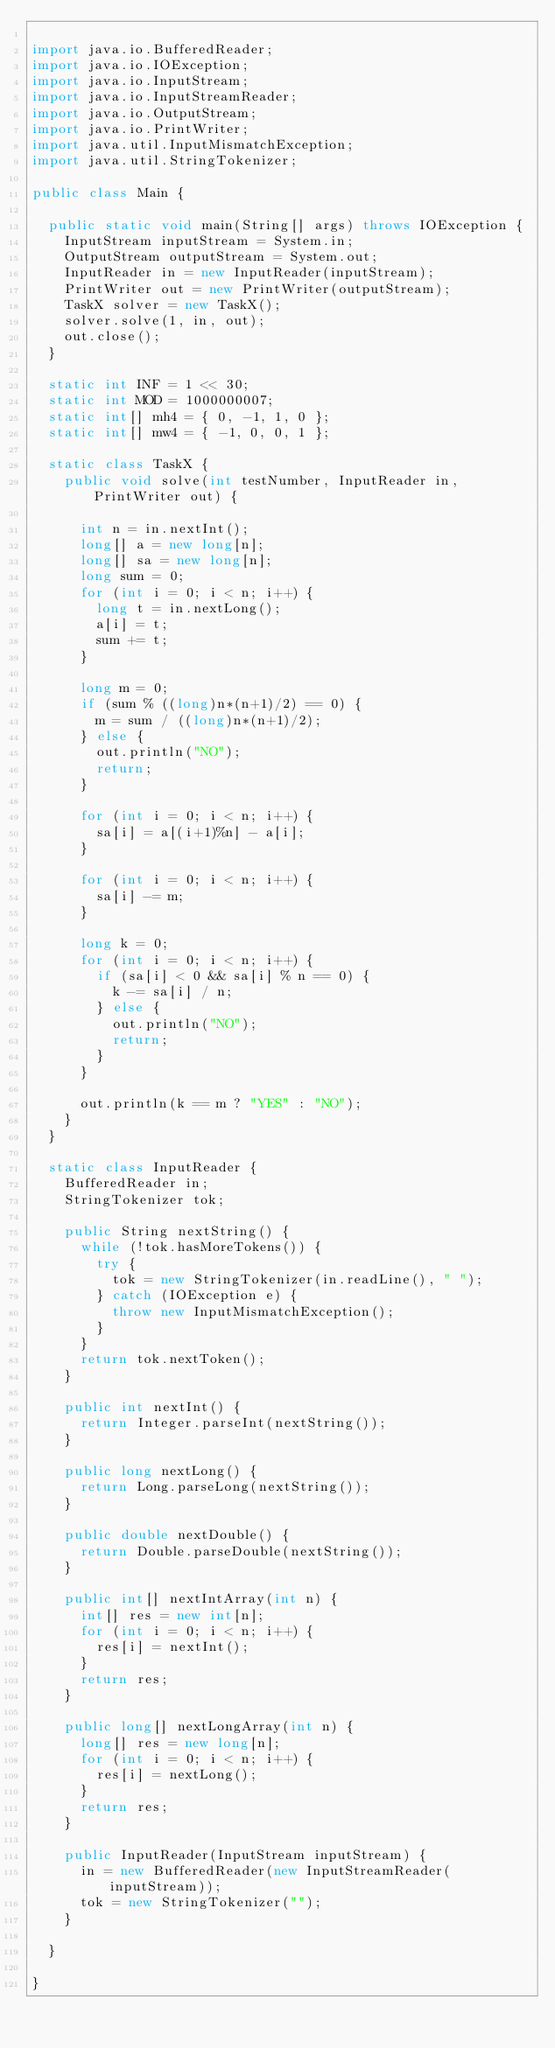Convert code to text. <code><loc_0><loc_0><loc_500><loc_500><_Java_>
import java.io.BufferedReader;
import java.io.IOException;
import java.io.InputStream;
import java.io.InputStreamReader;
import java.io.OutputStream;
import java.io.PrintWriter;
import java.util.InputMismatchException;
import java.util.StringTokenizer;

public class Main {

	public static void main(String[] args) throws IOException {
		InputStream inputStream = System.in;
		OutputStream outputStream = System.out;
		InputReader in = new InputReader(inputStream);
		PrintWriter out = new PrintWriter(outputStream);
		TaskX solver = new TaskX();
		solver.solve(1, in, out);
		out.close();
	}

	static int INF = 1 << 30;
	static int MOD = 1000000007;
	static int[] mh4 = { 0, -1, 1, 0 };
	static int[] mw4 = { -1, 0, 0, 1 };

	static class TaskX {
		public void solve(int testNumber, InputReader in, PrintWriter out) {

			int n = in.nextInt();
			long[] a = new long[n];
			long[] sa = new long[n];
			long sum = 0;
			for (int i = 0; i < n; i++) {
				long t = in.nextLong();
				a[i] = t;
				sum += t;
			}

			long m = 0;
			if (sum % ((long)n*(n+1)/2) == 0) {
				m = sum / ((long)n*(n+1)/2);
			} else {
				out.println("NO");
				return;
			}

			for (int i = 0; i < n; i++) {
				sa[i] = a[(i+1)%n] - a[i];
			}

			for (int i = 0; i < n; i++) {
				sa[i] -= m;
			}

			long k = 0;
			for (int i = 0; i < n; i++) {
				if (sa[i] < 0 && sa[i] % n == 0) {
					k -= sa[i] / n;
				} else {
					out.println("NO");
					return;
				}
			}

			out.println(k == m ? "YES" : "NO");
		}
	}

	static class InputReader {
		BufferedReader in;
		StringTokenizer tok;

		public String nextString() {
			while (!tok.hasMoreTokens()) {
				try {
					tok = new StringTokenizer(in.readLine(), " ");
				} catch (IOException e) {
					throw new InputMismatchException();
				}
			}
			return tok.nextToken();
		}

		public int nextInt() {
			return Integer.parseInt(nextString());
		}

		public long nextLong() {
			return Long.parseLong(nextString());
		}

		public double nextDouble() {
			return Double.parseDouble(nextString());
		}

		public int[] nextIntArray(int n) {
			int[] res = new int[n];
			for (int i = 0; i < n; i++) {
				res[i] = nextInt();
			}
			return res;
		}

		public long[] nextLongArray(int n) {
			long[] res = new long[n];
			for (int i = 0; i < n; i++) {
				res[i] = nextLong();
			}
			return res;
		}

		public InputReader(InputStream inputStream) {
			in = new BufferedReader(new InputStreamReader(inputStream));
			tok = new StringTokenizer("");
		}

	}

}
</code> 